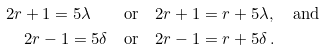Convert formula to latex. <formula><loc_0><loc_0><loc_500><loc_500>2 r + 1 = 5 \lambda \quad & \text {or} \quad 2 r + 1 = r + 5 \lambda , \quad \text {and} \\ 2 r - 1 = 5 \delta \quad & \text {or} \quad 2 r - 1 = r + 5 \delta \, .</formula> 